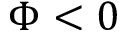<formula> <loc_0><loc_0><loc_500><loc_500>\Phi < 0</formula> 